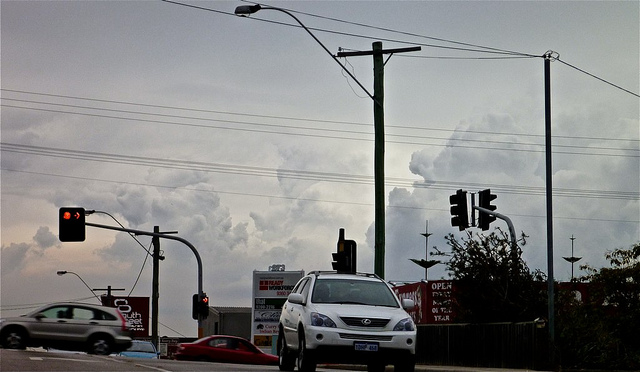<image>What is on the windshield? There is nothing on the windshield. It might be wipers or tinting, but I'm not sure. What street is the car crossing? I don't know what street the car is crossing. It can be either main street or unknown. What is on the windshield? I am not sure what is on the windshield. It can be seen nothing, wipers, tinting, or glass. What street is the car crossing? I don't know what street the car is crossing. It can be either "main" or "unknown". 